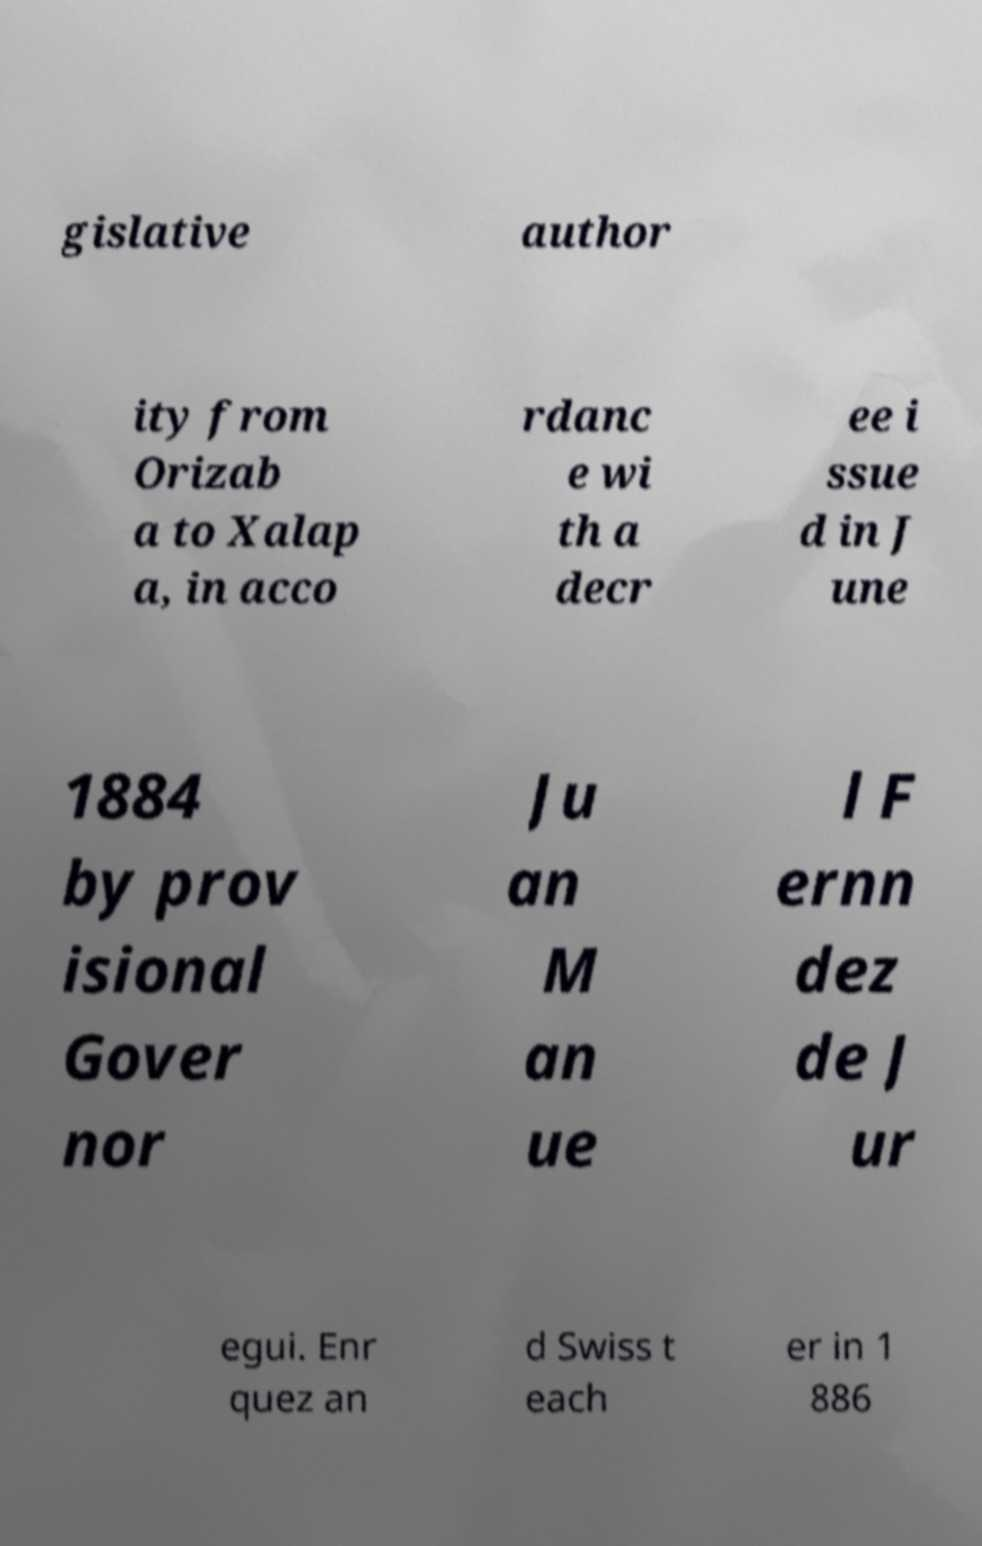Please identify and transcribe the text found in this image. gislative author ity from Orizab a to Xalap a, in acco rdanc e wi th a decr ee i ssue d in J une 1884 by prov isional Gover nor Ju an M an ue l F ernn dez de J ur egui. Enr quez an d Swiss t each er in 1 886 